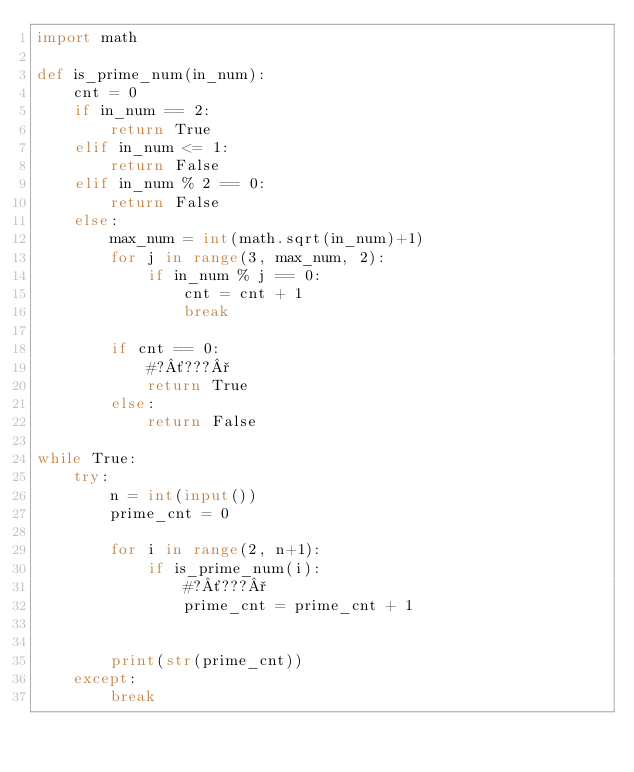<code> <loc_0><loc_0><loc_500><loc_500><_Python_>import math

def is_prime_num(in_num):
    cnt = 0
    if in_num == 2:
        return True
    elif in_num <= 1:
        return False
    elif in_num % 2 == 0:
        return False
    else:
        max_num = int(math.sqrt(in_num)+1)
        for j in range(3, max_num, 2):
            if in_num % j == 0:
                cnt = cnt + 1
                break
                    
        if cnt == 0:
            #?´???°
            return True
        else:
            return False

while True:
    try:
        n = int(input())
        prime_cnt = 0

        for i in range(2, n+1):
            if is_prime_num(i):
                #?´???°
                prime_cnt = prime_cnt + 1
                

        print(str(prime_cnt))
    except:
        break
    </code> 